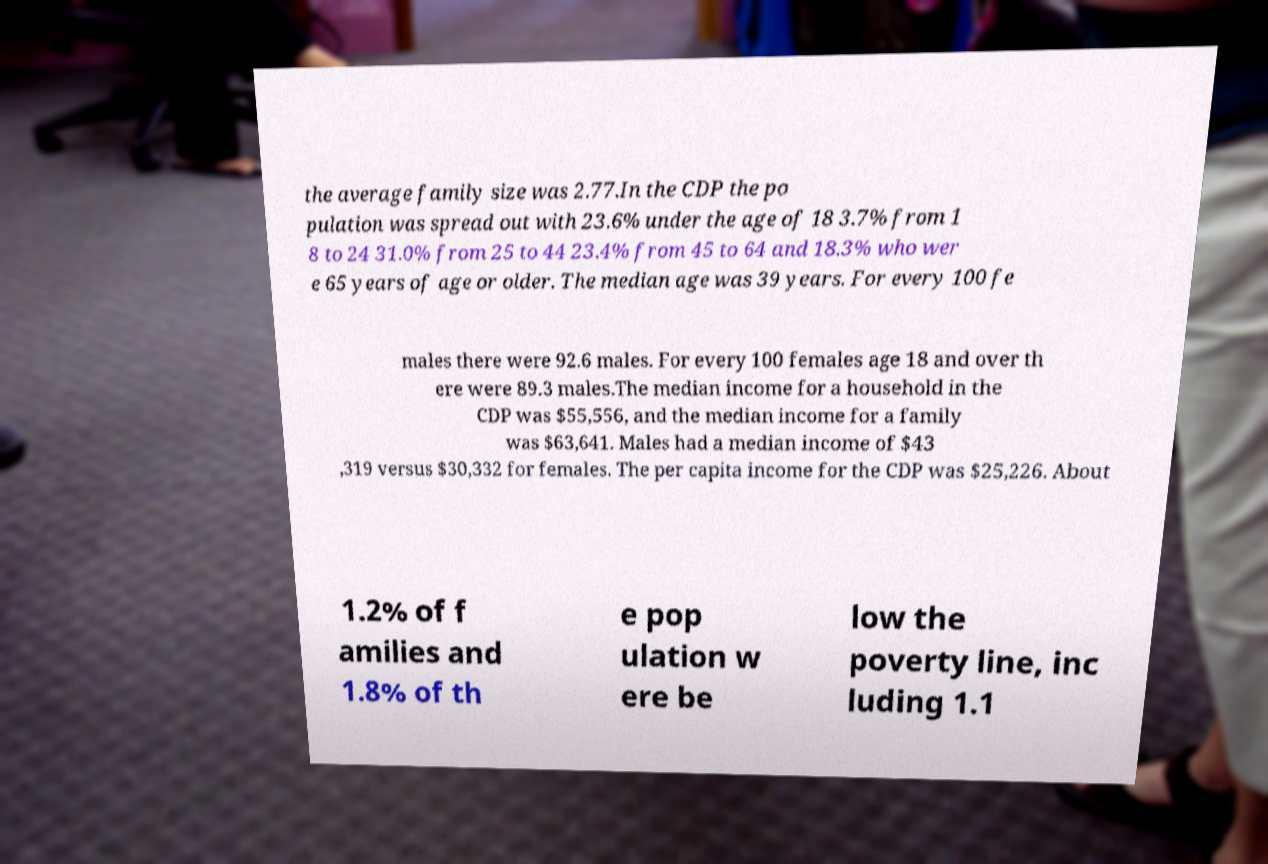Can you read and provide the text displayed in the image?This photo seems to have some interesting text. Can you extract and type it out for me? the average family size was 2.77.In the CDP the po pulation was spread out with 23.6% under the age of 18 3.7% from 1 8 to 24 31.0% from 25 to 44 23.4% from 45 to 64 and 18.3% who wer e 65 years of age or older. The median age was 39 years. For every 100 fe males there were 92.6 males. For every 100 females age 18 and over th ere were 89.3 males.The median income for a household in the CDP was $55,556, and the median income for a family was $63,641. Males had a median income of $43 ,319 versus $30,332 for females. The per capita income for the CDP was $25,226. About 1.2% of f amilies and 1.8% of th e pop ulation w ere be low the poverty line, inc luding 1.1 